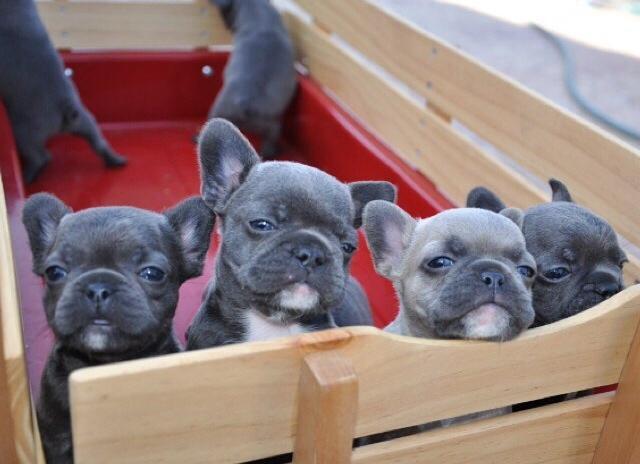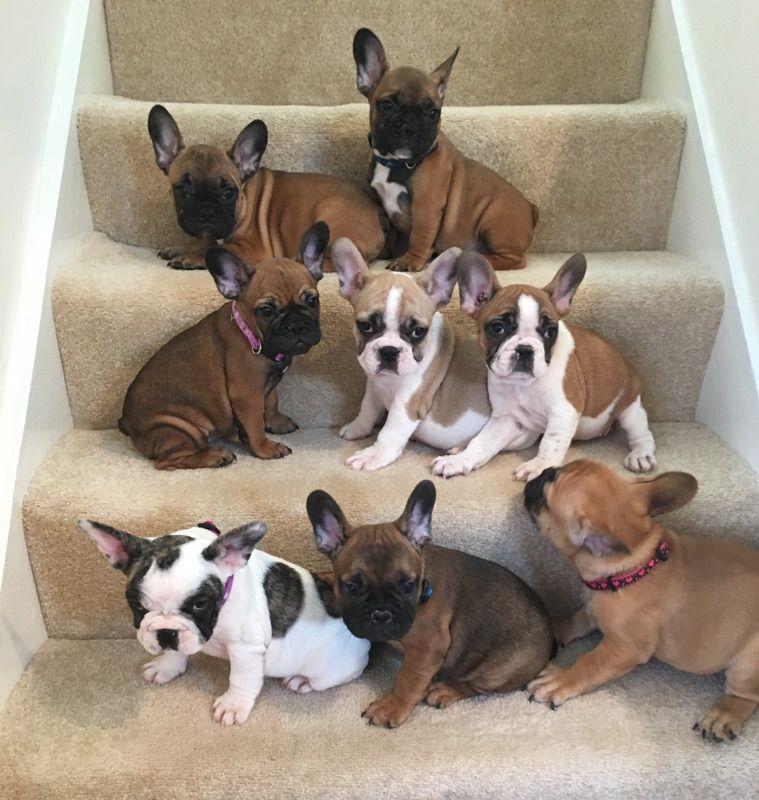The first image is the image on the left, the second image is the image on the right. For the images displayed, is the sentence "One image contains more than 7 puppies." factually correct? Answer yes or no. Yes. The first image is the image on the left, the second image is the image on the right. Examine the images to the left and right. Is the description "There are no more than four dogs in the right image." accurate? Answer yes or no. No. 